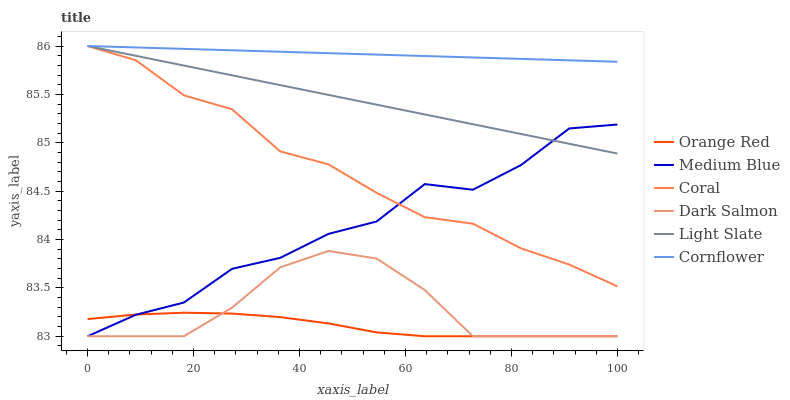Does Orange Red have the minimum area under the curve?
Answer yes or no. Yes. Does Cornflower have the maximum area under the curve?
Answer yes or no. Yes. Does Light Slate have the minimum area under the curve?
Answer yes or no. No. Does Light Slate have the maximum area under the curve?
Answer yes or no. No. Is Cornflower the smoothest?
Answer yes or no. Yes. Is Medium Blue the roughest?
Answer yes or no. Yes. Is Light Slate the smoothest?
Answer yes or no. No. Is Light Slate the roughest?
Answer yes or no. No. Does Medium Blue have the lowest value?
Answer yes or no. Yes. Does Light Slate have the lowest value?
Answer yes or no. No. Does Coral have the highest value?
Answer yes or no. Yes. Does Medium Blue have the highest value?
Answer yes or no. No. Is Orange Red less than Light Slate?
Answer yes or no. Yes. Is Light Slate greater than Orange Red?
Answer yes or no. Yes. Does Light Slate intersect Medium Blue?
Answer yes or no. Yes. Is Light Slate less than Medium Blue?
Answer yes or no. No. Is Light Slate greater than Medium Blue?
Answer yes or no. No. Does Orange Red intersect Light Slate?
Answer yes or no. No. 